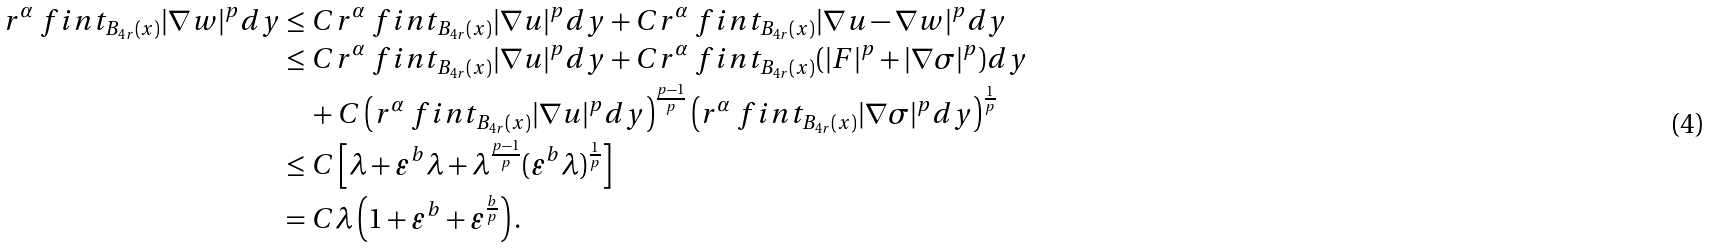<formula> <loc_0><loc_0><loc_500><loc_500>r ^ { \alpha } \ f i n t _ { B _ { 4 r } ( x ) } { | \nabla w | ^ { p } d y } & \leq C r ^ { \alpha } \ f i n t _ { B _ { 4 r } ( x ) } { | \nabla u | ^ { p } d y } + C r ^ { \alpha } \ f i n t _ { B _ { 4 r } ( x ) } { | \nabla u - \nabla w | ^ { p } d y } \\ & \leq C r ^ { \alpha } \ f i n t _ { B _ { 4 r } ( x ) } { | \nabla u | ^ { p } d y } + C r ^ { \alpha } \ f i n t _ { B _ { 4 r } ( x ) } { ( | F | ^ { p } + | \nabla \sigma | ^ { p } ) d y } \\ & \quad + C \left ( r ^ { \alpha } \ f i n t _ { B _ { 4 r } ( x ) } { | \nabla u | ^ { p } d y } \right ) ^ { \frac { p - 1 } { p } } \left ( r ^ { \alpha } \ f i n t _ { B _ { 4 r } ( x ) } { | \nabla \sigma | ^ { p } d y } \right ) ^ { \frac { 1 } { p } } \\ & \leq C \left [ \lambda + \varepsilon ^ { b } \lambda + \lambda ^ { \frac { p - 1 } { p } } ( \varepsilon ^ { b } \lambda ) ^ { \frac { 1 } { p } } \right ] \\ & = C \lambda \left ( 1 + \varepsilon ^ { b } + \varepsilon ^ { \frac { b } { p } } \right ) .</formula> 